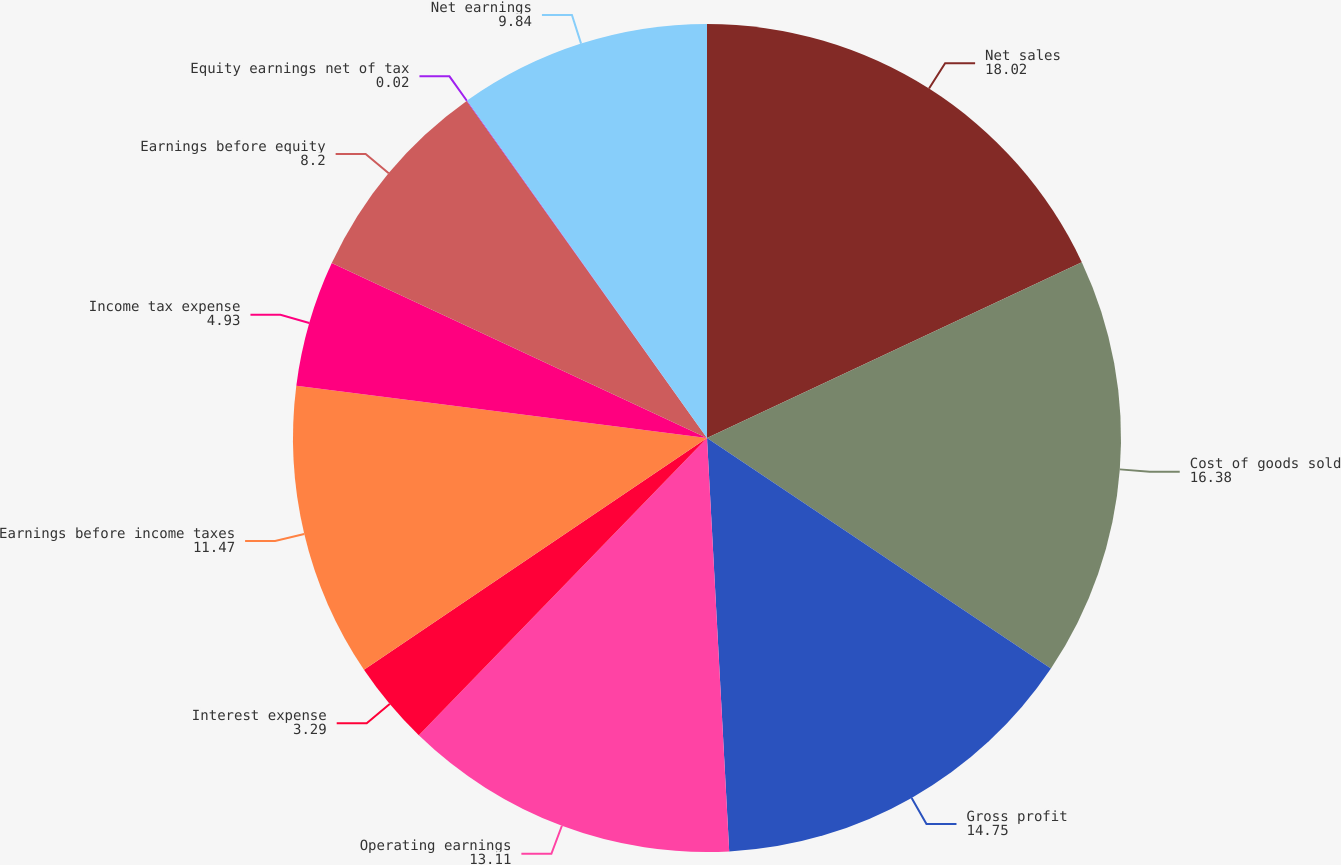Convert chart. <chart><loc_0><loc_0><loc_500><loc_500><pie_chart><fcel>Net sales<fcel>Cost of goods sold<fcel>Gross profit<fcel>Operating earnings<fcel>Interest expense<fcel>Earnings before income taxes<fcel>Income tax expense<fcel>Earnings before equity<fcel>Equity earnings net of tax<fcel>Net earnings<nl><fcel>18.02%<fcel>16.38%<fcel>14.75%<fcel>13.11%<fcel>3.29%<fcel>11.47%<fcel>4.93%<fcel>8.2%<fcel>0.02%<fcel>9.84%<nl></chart> 